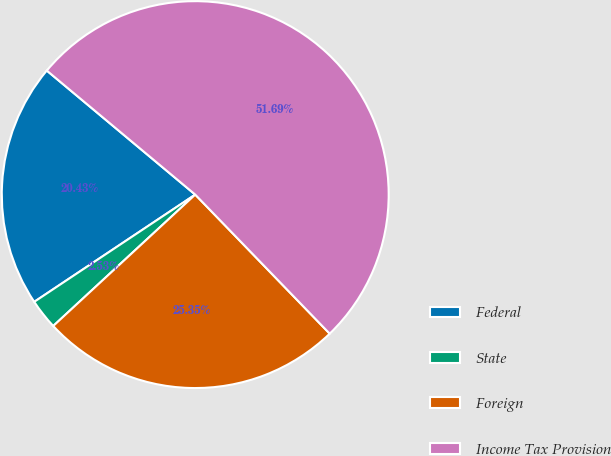Convert chart to OTSL. <chart><loc_0><loc_0><loc_500><loc_500><pie_chart><fcel>Federal<fcel>State<fcel>Foreign<fcel>Income Tax Provision<nl><fcel>20.43%<fcel>2.53%<fcel>25.35%<fcel>51.69%<nl></chart> 